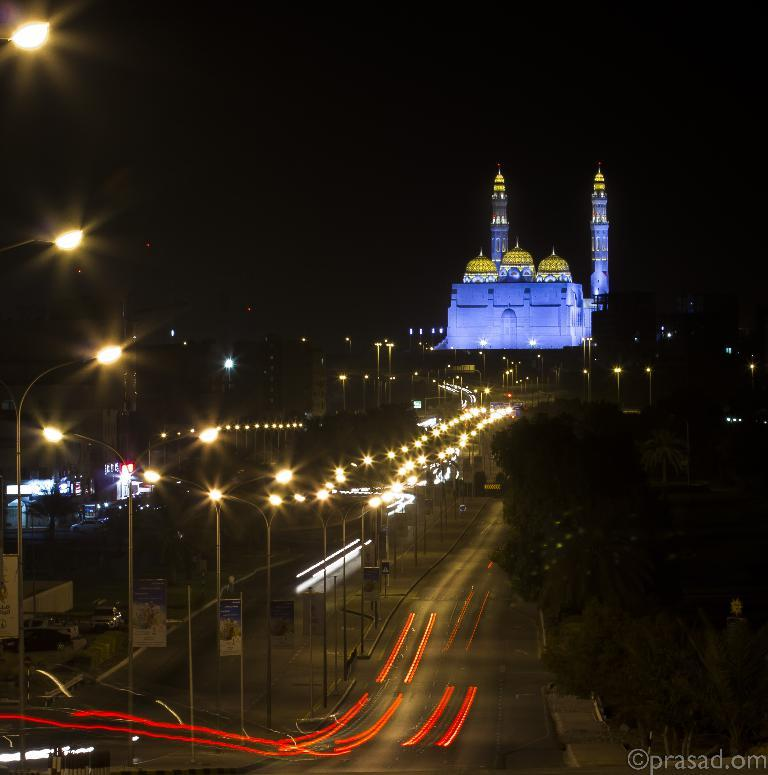What can be seen in the foreground of the image? In the foreground of the image, there are lamp poles, vehicles, and posters. What time of day does the image appear to be captured? The image appears to be captured during night time. Can you describe any specific features of the vehicles in the foreground? Unfortunately, the provided facts do not mention any specific features of the vehicles. Are there any structures or objects in the background of the image? The provided facts do not explicitly mention any structures or objects in the background of the image, but it is possible that there may be buildings present. How many letters are being delivered by the earth in the image? There is no earth or letters present in the image. Is there a bath visible in the image? No, there is no bath visible in the image. 